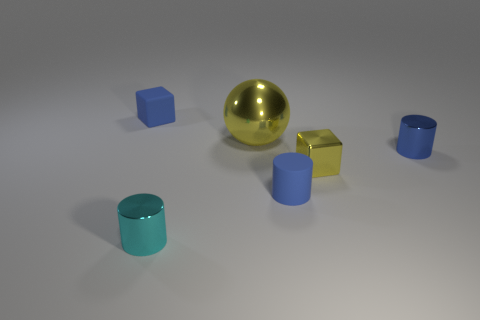Add 3 metallic blocks. How many objects exist? 9 Subtract all blocks. How many objects are left? 4 Add 5 tiny cyan shiny objects. How many tiny cyan shiny objects are left? 6 Add 5 tiny cyan matte spheres. How many tiny cyan matte spheres exist? 5 Subtract 1 yellow blocks. How many objects are left? 5 Subtract all small brown metal cylinders. Subtract all large yellow objects. How many objects are left? 5 